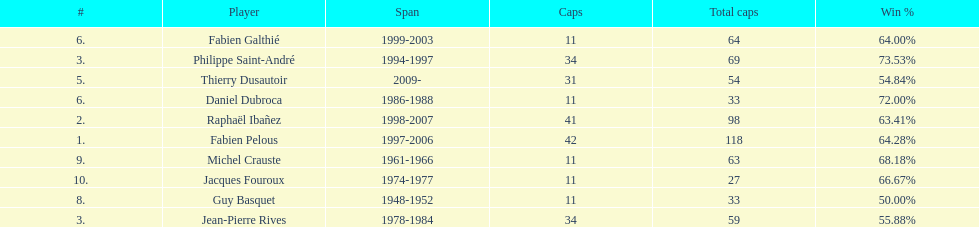Help me parse the entirety of this table. {'header': ['#', 'Player', 'Span', 'Caps', 'Total caps', 'Win\xa0%'], 'rows': [['6.', 'Fabien Galthié', '1999-2003', '11', '64', '64.00%'], ['3.', 'Philippe Saint-André', '1994-1997', '34', '69', '73.53%'], ['5.', 'Thierry Dusautoir', '2009-', '31', '54', '54.84%'], ['6.', 'Daniel Dubroca', '1986-1988', '11', '33', '72.00%'], ['2.', 'Raphaël Ibañez', '1998-2007', '41', '98', '63.41%'], ['1.', 'Fabien Pelous', '1997-2006', '42', '118', '64.28%'], ['9.', 'Michel Crauste', '1961-1966', '11', '63', '68.18%'], ['10.', 'Jacques Fouroux', '1974-1977', '11', '27', '66.67%'], ['8.', 'Guy Basquet', '1948-1952', '11', '33', '50.00%'], ['3.', 'Jean-Pierre Rives', '1978-1984', '34', '59', '55.88%']]} How many captains played 11 capped matches? 5. 